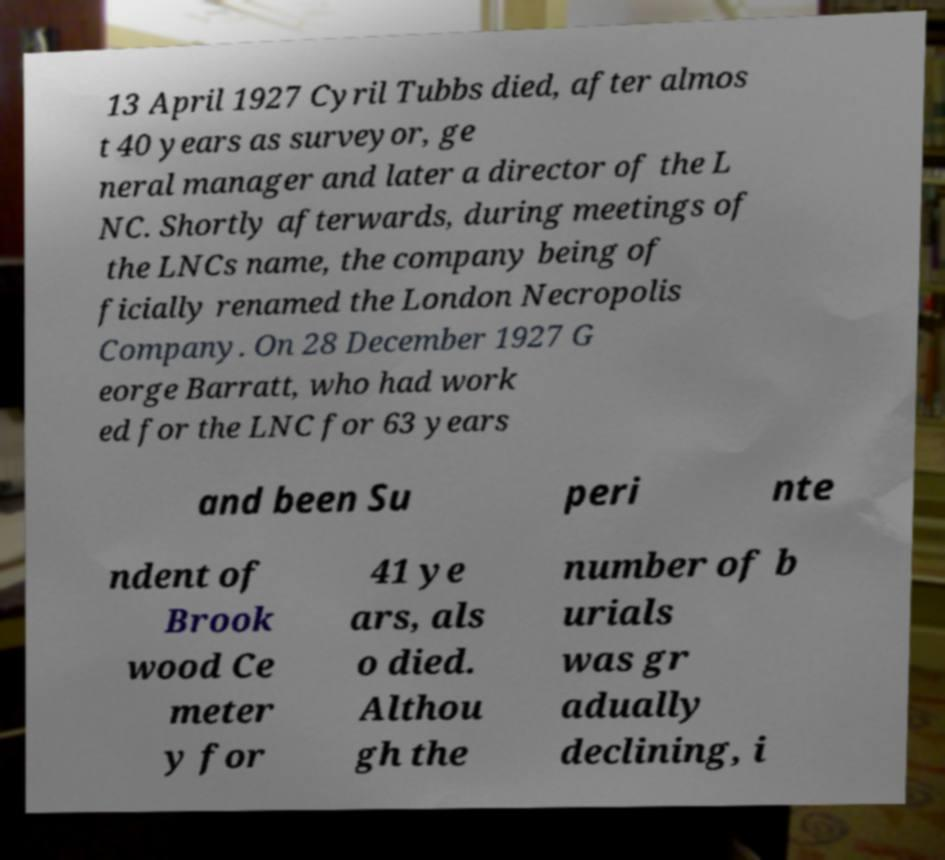Can you accurately transcribe the text from the provided image for me? 13 April 1927 Cyril Tubbs died, after almos t 40 years as surveyor, ge neral manager and later a director of the L NC. Shortly afterwards, during meetings of the LNCs name, the company being of ficially renamed the London Necropolis Company. On 28 December 1927 G eorge Barratt, who had work ed for the LNC for 63 years and been Su peri nte ndent of Brook wood Ce meter y for 41 ye ars, als o died. Althou gh the number of b urials was gr adually declining, i 